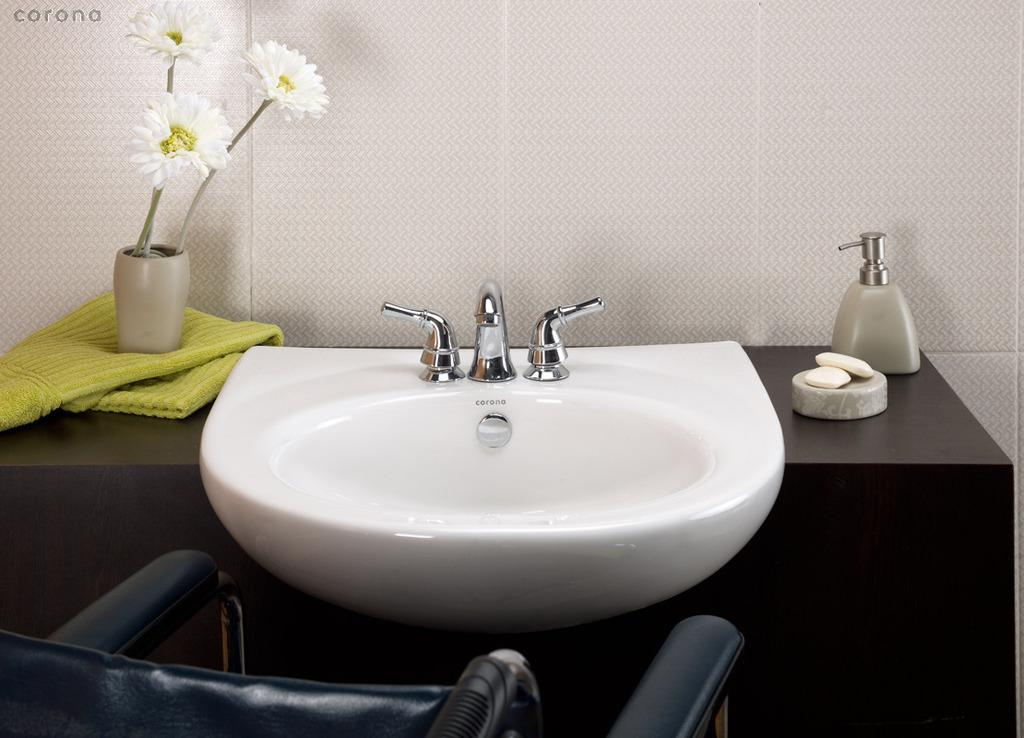What can be seen in the image that is typically used for holding flowers? There is a flower vase in the image. What type of material is present in the image that can be used for cleaning or covering? There is a cloth in the image. What is the primary feature of the image that is used for washing hands or dishes? There is a sink in the image. What are the two objects in the image that control the flow of water? There are taps in the image. What can be seen in the image that is used for cleaning hands or dishes? There are soaps in the image. What is the object in the image that is used for storing liquid? There is a bottle in the image. What is the unspecified object in the image? There are other unspecified objects in the image. What can be seen in the background of the image? There is a wall visible in the background of the image. How many clovers are growing on the wall in the image? There are no clovers visible in the image; only a wall is present in the background. What type of lipstick is being used by the person in the image? There is no person or lipstick present in the image. 